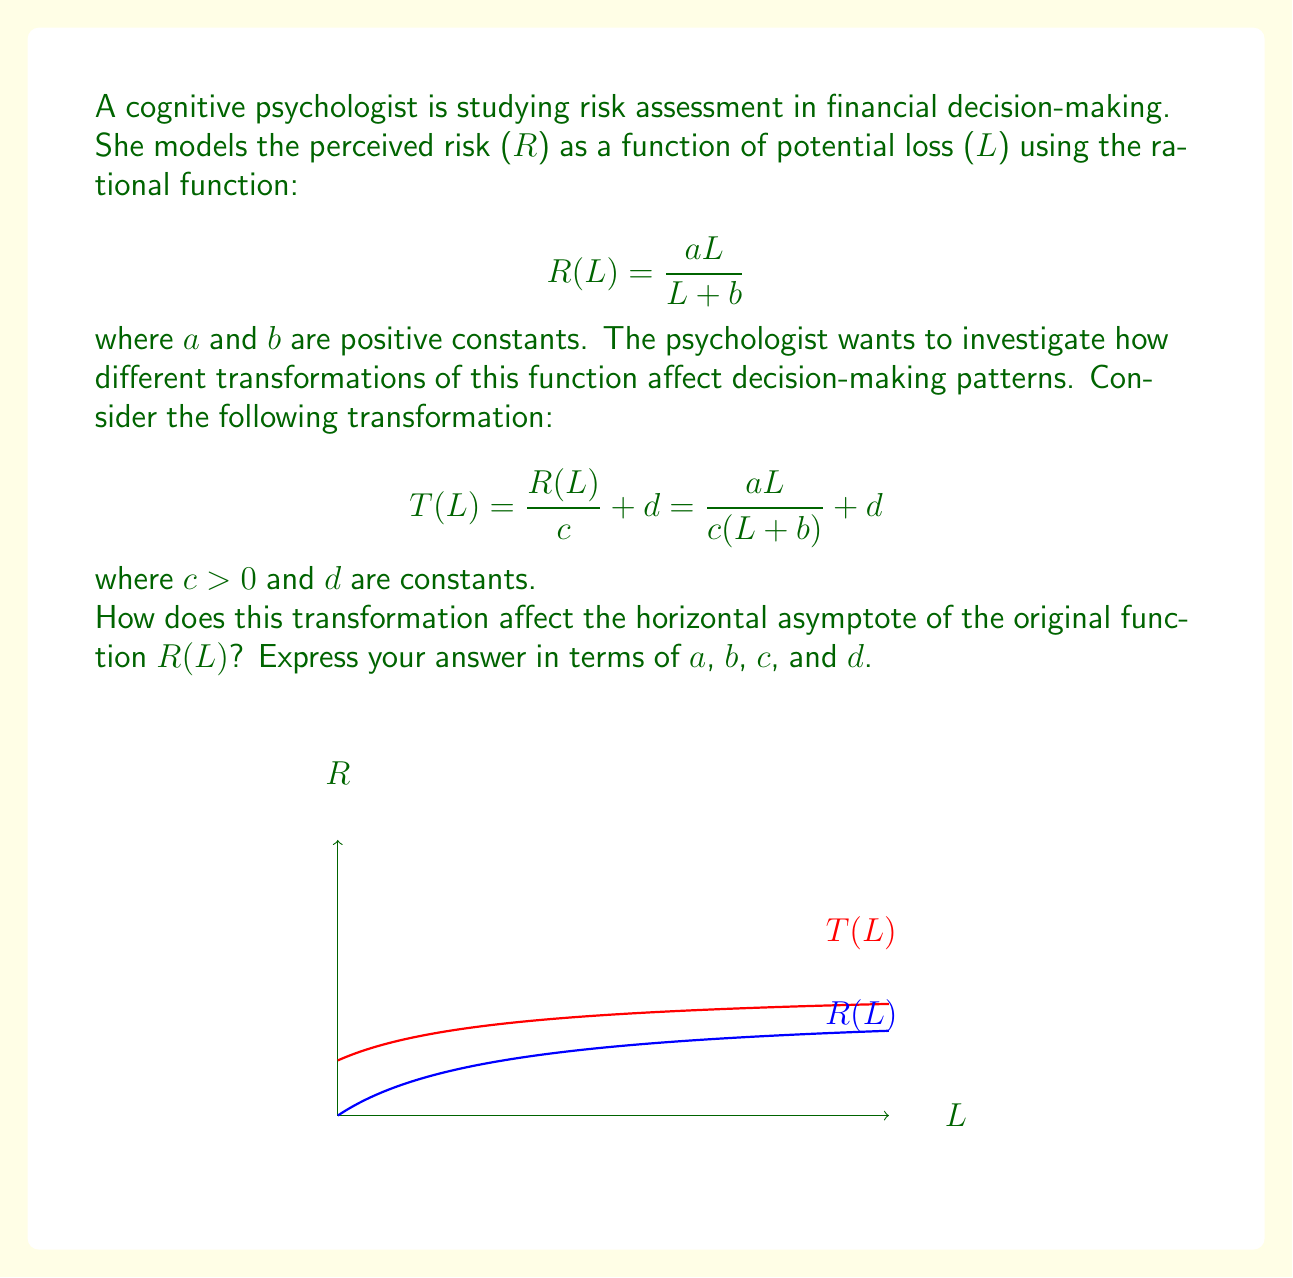Teach me how to tackle this problem. Let's approach this step-by-step:

1) First, recall that the horizontal asymptote of a rational function is determined by comparing the degrees of the numerator and denominator.

2) For the original function R(L):
   $$R(L) = \frac{aL}{L + b}$$
   The degree of both numerator and denominator is 1, so the horizontal asymptote is:
   $$\lim_{L \to \infty} R(L) = \frac{a}{1} = a$$

3) Now, let's consider the transformed function T(L):
   $$T(L) = \frac{R(L)}{c} + d = \frac{aL}{c(L + b)} + d$$

4) To find the horizontal asymptote of T(L), we need to evaluate:
   $$\lim_{L \to \infty} T(L) = \lim_{L \to \infty} (\frac{aL}{c(L + b)} + d)$$

5) Let's focus on the fraction part:
   $$\lim_{L \to \infty} \frac{aL}{c(L + b)} = \lim_{L \to \infty} \frac{a}{c(1 + \frac{b}{L})} = \frac{a}{c}$$

6) Therefore, the full limit is:
   $$\lim_{L \to \infty} T(L) = \frac{a}{c} + d$$

7) This value represents the new horizontal asymptote for the transformed function T(L).

8) Comparing to the original function, we can see that the transformation has:
   - Divided the original asymptote (a) by c
   - Shifted the result vertically by d
Answer: $$\frac{a}{c} + d$$ 